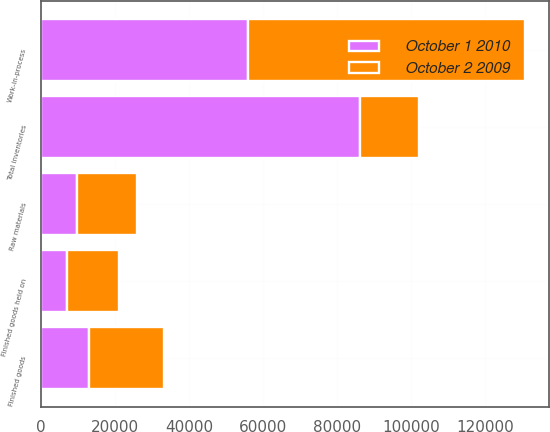Convert chart to OTSL. <chart><loc_0><loc_0><loc_500><loc_500><stacked_bar_chart><ecel><fcel>Raw materials<fcel>Work-in-process<fcel>Finished goods<fcel>Finished goods held on<fcel>Total inventories<nl><fcel>October 2 2009<fcel>16108<fcel>74701<fcel>20209<fcel>14041<fcel>16108<nl><fcel>October 1 2010<fcel>9889<fcel>56074<fcel>12950<fcel>7184<fcel>86097<nl></chart> 